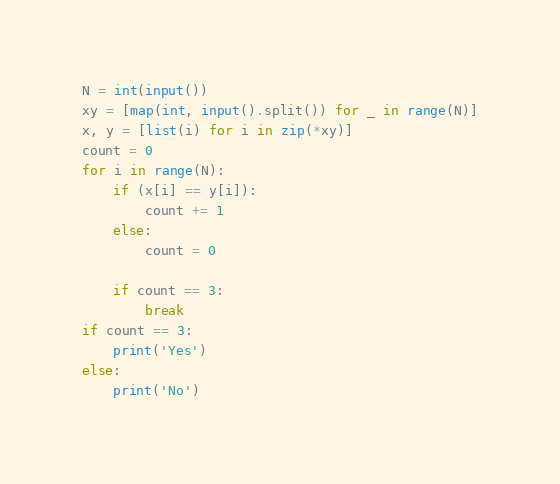Convert code to text. <code><loc_0><loc_0><loc_500><loc_500><_Python_>N = int(input())
xy = [map(int, input().split()) for _ in range(N)]
x, y = [list(i) for i in zip(*xy)]
count = 0
for i in range(N):
    if (x[i] == y[i]):
        count += 1
    else:
        count = 0
    
    if count == 3:
        break
if count == 3:
    print('Yes')
else:
    print('No')</code> 